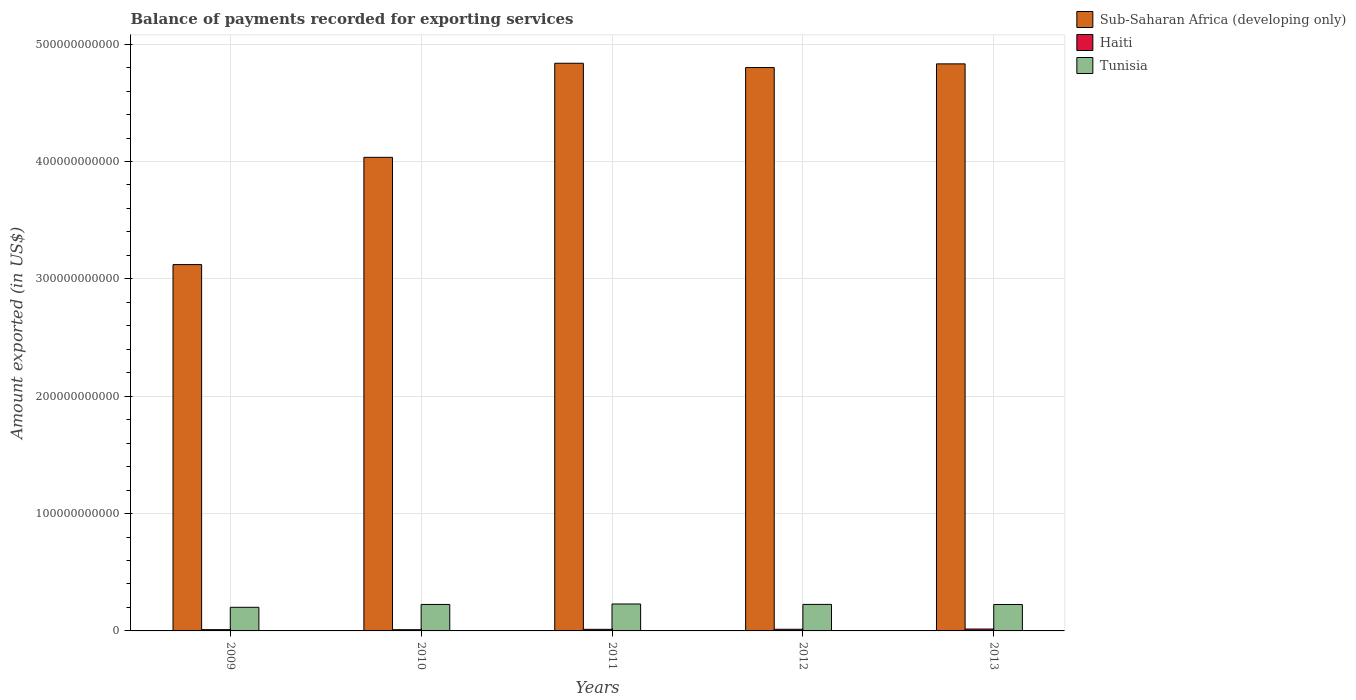How many groups of bars are there?
Offer a terse response. 5. How many bars are there on the 1st tick from the right?
Provide a short and direct response. 3. What is the amount exported in Haiti in 2010?
Keep it short and to the point. 1.05e+09. Across all years, what is the maximum amount exported in Sub-Saharan Africa (developing only)?
Ensure brevity in your answer.  4.84e+11. Across all years, what is the minimum amount exported in Sub-Saharan Africa (developing only)?
Make the answer very short. 3.12e+11. In which year was the amount exported in Haiti maximum?
Your answer should be very brief. 2013. What is the total amount exported in Sub-Saharan Africa (developing only) in the graph?
Make the answer very short. 2.16e+12. What is the difference between the amount exported in Sub-Saharan Africa (developing only) in 2011 and that in 2013?
Ensure brevity in your answer.  5.22e+08. What is the difference between the amount exported in Haiti in 2011 and the amount exported in Tunisia in 2009?
Your answer should be compact. -1.88e+1. What is the average amount exported in Tunisia per year?
Keep it short and to the point. 2.22e+1. In the year 2011, what is the difference between the amount exported in Sub-Saharan Africa (developing only) and amount exported in Haiti?
Your answer should be very brief. 4.82e+11. What is the ratio of the amount exported in Tunisia in 2009 to that in 2013?
Offer a terse response. 0.89. Is the amount exported in Sub-Saharan Africa (developing only) in 2009 less than that in 2012?
Your response must be concise. Yes. Is the difference between the amount exported in Sub-Saharan Africa (developing only) in 2010 and 2012 greater than the difference between the amount exported in Haiti in 2010 and 2012?
Offer a very short reply. No. What is the difference between the highest and the second highest amount exported in Tunisia?
Offer a very short reply. 3.50e+08. What is the difference between the highest and the lowest amount exported in Tunisia?
Keep it short and to the point. 2.82e+09. Is the sum of the amount exported in Haiti in 2011 and 2013 greater than the maximum amount exported in Tunisia across all years?
Your response must be concise. No. What does the 3rd bar from the left in 2010 represents?
Your response must be concise. Tunisia. What does the 1st bar from the right in 2011 represents?
Keep it short and to the point. Tunisia. How many bars are there?
Your answer should be very brief. 15. What is the difference between two consecutive major ticks on the Y-axis?
Your answer should be compact. 1.00e+11. Does the graph contain any zero values?
Keep it short and to the point. No. Where does the legend appear in the graph?
Offer a very short reply. Top right. How many legend labels are there?
Your answer should be very brief. 3. How are the legend labels stacked?
Make the answer very short. Vertical. What is the title of the graph?
Offer a very short reply. Balance of payments recorded for exporting services. Does "Haiti" appear as one of the legend labels in the graph?
Make the answer very short. Yes. What is the label or title of the Y-axis?
Provide a short and direct response. Amount exported (in US$). What is the Amount exported (in US$) of Sub-Saharan Africa (developing only) in 2009?
Your answer should be very brief. 3.12e+11. What is the Amount exported (in US$) of Haiti in 2009?
Ensure brevity in your answer.  1.07e+09. What is the Amount exported (in US$) in Tunisia in 2009?
Offer a very short reply. 2.01e+1. What is the Amount exported (in US$) of Sub-Saharan Africa (developing only) in 2010?
Your response must be concise. 4.04e+11. What is the Amount exported (in US$) in Haiti in 2010?
Offer a terse response. 1.05e+09. What is the Amount exported (in US$) of Tunisia in 2010?
Your response must be concise. 2.26e+1. What is the Amount exported (in US$) of Sub-Saharan Africa (developing only) in 2011?
Give a very brief answer. 4.84e+11. What is the Amount exported (in US$) of Haiti in 2011?
Offer a terse response. 1.36e+09. What is the Amount exported (in US$) in Tunisia in 2011?
Your response must be concise. 2.30e+1. What is the Amount exported (in US$) of Sub-Saharan Africa (developing only) in 2012?
Your answer should be compact. 4.80e+11. What is the Amount exported (in US$) of Haiti in 2012?
Your answer should be very brief. 1.40e+09. What is the Amount exported (in US$) in Tunisia in 2012?
Give a very brief answer. 2.26e+1. What is the Amount exported (in US$) in Sub-Saharan Africa (developing only) in 2013?
Provide a succinct answer. 4.83e+11. What is the Amount exported (in US$) of Haiti in 2013?
Your response must be concise. 1.61e+09. What is the Amount exported (in US$) in Tunisia in 2013?
Ensure brevity in your answer.  2.25e+1. Across all years, what is the maximum Amount exported (in US$) in Sub-Saharan Africa (developing only)?
Offer a terse response. 4.84e+11. Across all years, what is the maximum Amount exported (in US$) of Haiti?
Give a very brief answer. 1.61e+09. Across all years, what is the maximum Amount exported (in US$) of Tunisia?
Your response must be concise. 2.30e+1. Across all years, what is the minimum Amount exported (in US$) in Sub-Saharan Africa (developing only)?
Your answer should be compact. 3.12e+11. Across all years, what is the minimum Amount exported (in US$) of Haiti?
Provide a short and direct response. 1.05e+09. Across all years, what is the minimum Amount exported (in US$) of Tunisia?
Your answer should be compact. 2.01e+1. What is the total Amount exported (in US$) in Sub-Saharan Africa (developing only) in the graph?
Your answer should be very brief. 2.16e+12. What is the total Amount exported (in US$) of Haiti in the graph?
Make the answer very short. 6.48e+09. What is the total Amount exported (in US$) of Tunisia in the graph?
Your answer should be very brief. 1.11e+11. What is the difference between the Amount exported (in US$) of Sub-Saharan Africa (developing only) in 2009 and that in 2010?
Offer a very short reply. -9.14e+1. What is the difference between the Amount exported (in US$) of Haiti in 2009 and that in 2010?
Ensure brevity in your answer.  1.60e+07. What is the difference between the Amount exported (in US$) of Tunisia in 2009 and that in 2010?
Offer a terse response. -2.42e+09. What is the difference between the Amount exported (in US$) in Sub-Saharan Africa (developing only) in 2009 and that in 2011?
Keep it short and to the point. -1.72e+11. What is the difference between the Amount exported (in US$) in Haiti in 2009 and that in 2011?
Provide a succinct answer. -2.91e+08. What is the difference between the Amount exported (in US$) in Tunisia in 2009 and that in 2011?
Your answer should be compact. -2.82e+09. What is the difference between the Amount exported (in US$) in Sub-Saharan Africa (developing only) in 2009 and that in 2012?
Provide a succinct answer. -1.68e+11. What is the difference between the Amount exported (in US$) of Haiti in 2009 and that in 2012?
Your response must be concise. -3.35e+08. What is the difference between the Amount exported (in US$) of Tunisia in 2009 and that in 2012?
Keep it short and to the point. -2.47e+09. What is the difference between the Amount exported (in US$) in Sub-Saharan Africa (developing only) in 2009 and that in 2013?
Give a very brief answer. -1.71e+11. What is the difference between the Amount exported (in US$) in Haiti in 2009 and that in 2013?
Ensure brevity in your answer.  -5.43e+08. What is the difference between the Amount exported (in US$) of Tunisia in 2009 and that in 2013?
Provide a succinct answer. -2.38e+09. What is the difference between the Amount exported (in US$) of Sub-Saharan Africa (developing only) in 2010 and that in 2011?
Keep it short and to the point. -8.02e+1. What is the difference between the Amount exported (in US$) of Haiti in 2010 and that in 2011?
Your answer should be compact. -3.07e+08. What is the difference between the Amount exported (in US$) of Tunisia in 2010 and that in 2011?
Your answer should be very brief. -3.94e+08. What is the difference between the Amount exported (in US$) of Sub-Saharan Africa (developing only) in 2010 and that in 2012?
Your answer should be very brief. -7.65e+1. What is the difference between the Amount exported (in US$) of Haiti in 2010 and that in 2012?
Give a very brief answer. -3.51e+08. What is the difference between the Amount exported (in US$) in Tunisia in 2010 and that in 2012?
Your answer should be very brief. -4.48e+07. What is the difference between the Amount exported (in US$) of Sub-Saharan Africa (developing only) in 2010 and that in 2013?
Your answer should be very brief. -7.96e+1. What is the difference between the Amount exported (in US$) of Haiti in 2010 and that in 2013?
Make the answer very short. -5.59e+08. What is the difference between the Amount exported (in US$) in Tunisia in 2010 and that in 2013?
Provide a short and direct response. 4.27e+07. What is the difference between the Amount exported (in US$) of Sub-Saharan Africa (developing only) in 2011 and that in 2012?
Ensure brevity in your answer.  3.65e+09. What is the difference between the Amount exported (in US$) in Haiti in 2011 and that in 2012?
Provide a succinct answer. -4.43e+07. What is the difference between the Amount exported (in US$) in Tunisia in 2011 and that in 2012?
Your answer should be very brief. 3.50e+08. What is the difference between the Amount exported (in US$) of Sub-Saharan Africa (developing only) in 2011 and that in 2013?
Ensure brevity in your answer.  5.22e+08. What is the difference between the Amount exported (in US$) in Haiti in 2011 and that in 2013?
Make the answer very short. -2.52e+08. What is the difference between the Amount exported (in US$) in Tunisia in 2011 and that in 2013?
Ensure brevity in your answer.  4.37e+08. What is the difference between the Amount exported (in US$) in Sub-Saharan Africa (developing only) in 2012 and that in 2013?
Ensure brevity in your answer.  -3.13e+09. What is the difference between the Amount exported (in US$) in Haiti in 2012 and that in 2013?
Your answer should be very brief. -2.08e+08. What is the difference between the Amount exported (in US$) in Tunisia in 2012 and that in 2013?
Provide a short and direct response. 8.75e+07. What is the difference between the Amount exported (in US$) of Sub-Saharan Africa (developing only) in 2009 and the Amount exported (in US$) of Haiti in 2010?
Your answer should be compact. 3.11e+11. What is the difference between the Amount exported (in US$) of Sub-Saharan Africa (developing only) in 2009 and the Amount exported (in US$) of Tunisia in 2010?
Ensure brevity in your answer.  2.90e+11. What is the difference between the Amount exported (in US$) of Haiti in 2009 and the Amount exported (in US$) of Tunisia in 2010?
Offer a terse response. -2.15e+1. What is the difference between the Amount exported (in US$) of Sub-Saharan Africa (developing only) in 2009 and the Amount exported (in US$) of Haiti in 2011?
Offer a terse response. 3.11e+11. What is the difference between the Amount exported (in US$) in Sub-Saharan Africa (developing only) in 2009 and the Amount exported (in US$) in Tunisia in 2011?
Your answer should be compact. 2.89e+11. What is the difference between the Amount exported (in US$) of Haiti in 2009 and the Amount exported (in US$) of Tunisia in 2011?
Your answer should be very brief. -2.19e+1. What is the difference between the Amount exported (in US$) of Sub-Saharan Africa (developing only) in 2009 and the Amount exported (in US$) of Haiti in 2012?
Offer a terse response. 3.11e+11. What is the difference between the Amount exported (in US$) of Sub-Saharan Africa (developing only) in 2009 and the Amount exported (in US$) of Tunisia in 2012?
Offer a terse response. 2.90e+11. What is the difference between the Amount exported (in US$) in Haiti in 2009 and the Amount exported (in US$) in Tunisia in 2012?
Offer a very short reply. -2.15e+1. What is the difference between the Amount exported (in US$) in Sub-Saharan Africa (developing only) in 2009 and the Amount exported (in US$) in Haiti in 2013?
Give a very brief answer. 3.11e+11. What is the difference between the Amount exported (in US$) of Sub-Saharan Africa (developing only) in 2009 and the Amount exported (in US$) of Tunisia in 2013?
Give a very brief answer. 2.90e+11. What is the difference between the Amount exported (in US$) of Haiti in 2009 and the Amount exported (in US$) of Tunisia in 2013?
Offer a terse response. -2.14e+1. What is the difference between the Amount exported (in US$) in Sub-Saharan Africa (developing only) in 2010 and the Amount exported (in US$) in Haiti in 2011?
Ensure brevity in your answer.  4.02e+11. What is the difference between the Amount exported (in US$) of Sub-Saharan Africa (developing only) in 2010 and the Amount exported (in US$) of Tunisia in 2011?
Your response must be concise. 3.81e+11. What is the difference between the Amount exported (in US$) in Haiti in 2010 and the Amount exported (in US$) in Tunisia in 2011?
Provide a succinct answer. -2.19e+1. What is the difference between the Amount exported (in US$) of Sub-Saharan Africa (developing only) in 2010 and the Amount exported (in US$) of Haiti in 2012?
Offer a very short reply. 4.02e+11. What is the difference between the Amount exported (in US$) in Sub-Saharan Africa (developing only) in 2010 and the Amount exported (in US$) in Tunisia in 2012?
Provide a short and direct response. 3.81e+11. What is the difference between the Amount exported (in US$) of Haiti in 2010 and the Amount exported (in US$) of Tunisia in 2012?
Offer a very short reply. -2.16e+1. What is the difference between the Amount exported (in US$) in Sub-Saharan Africa (developing only) in 2010 and the Amount exported (in US$) in Haiti in 2013?
Make the answer very short. 4.02e+11. What is the difference between the Amount exported (in US$) in Sub-Saharan Africa (developing only) in 2010 and the Amount exported (in US$) in Tunisia in 2013?
Offer a terse response. 3.81e+11. What is the difference between the Amount exported (in US$) in Haiti in 2010 and the Amount exported (in US$) in Tunisia in 2013?
Provide a short and direct response. -2.15e+1. What is the difference between the Amount exported (in US$) in Sub-Saharan Africa (developing only) in 2011 and the Amount exported (in US$) in Haiti in 2012?
Your response must be concise. 4.82e+11. What is the difference between the Amount exported (in US$) in Sub-Saharan Africa (developing only) in 2011 and the Amount exported (in US$) in Tunisia in 2012?
Keep it short and to the point. 4.61e+11. What is the difference between the Amount exported (in US$) in Haiti in 2011 and the Amount exported (in US$) in Tunisia in 2012?
Your response must be concise. -2.12e+1. What is the difference between the Amount exported (in US$) in Sub-Saharan Africa (developing only) in 2011 and the Amount exported (in US$) in Haiti in 2013?
Ensure brevity in your answer.  4.82e+11. What is the difference between the Amount exported (in US$) in Sub-Saharan Africa (developing only) in 2011 and the Amount exported (in US$) in Tunisia in 2013?
Your answer should be very brief. 4.61e+11. What is the difference between the Amount exported (in US$) of Haiti in 2011 and the Amount exported (in US$) of Tunisia in 2013?
Give a very brief answer. -2.12e+1. What is the difference between the Amount exported (in US$) in Sub-Saharan Africa (developing only) in 2012 and the Amount exported (in US$) in Haiti in 2013?
Your answer should be very brief. 4.78e+11. What is the difference between the Amount exported (in US$) of Sub-Saharan Africa (developing only) in 2012 and the Amount exported (in US$) of Tunisia in 2013?
Your answer should be very brief. 4.58e+11. What is the difference between the Amount exported (in US$) in Haiti in 2012 and the Amount exported (in US$) in Tunisia in 2013?
Provide a succinct answer. -2.11e+1. What is the average Amount exported (in US$) in Sub-Saharan Africa (developing only) per year?
Provide a short and direct response. 4.33e+11. What is the average Amount exported (in US$) in Haiti per year?
Your answer should be compact. 1.30e+09. What is the average Amount exported (in US$) in Tunisia per year?
Your answer should be compact. 2.22e+1. In the year 2009, what is the difference between the Amount exported (in US$) of Sub-Saharan Africa (developing only) and Amount exported (in US$) of Haiti?
Your response must be concise. 3.11e+11. In the year 2009, what is the difference between the Amount exported (in US$) of Sub-Saharan Africa (developing only) and Amount exported (in US$) of Tunisia?
Offer a terse response. 2.92e+11. In the year 2009, what is the difference between the Amount exported (in US$) in Haiti and Amount exported (in US$) in Tunisia?
Provide a short and direct response. -1.91e+1. In the year 2010, what is the difference between the Amount exported (in US$) in Sub-Saharan Africa (developing only) and Amount exported (in US$) in Haiti?
Your answer should be very brief. 4.02e+11. In the year 2010, what is the difference between the Amount exported (in US$) of Sub-Saharan Africa (developing only) and Amount exported (in US$) of Tunisia?
Your answer should be very brief. 3.81e+11. In the year 2010, what is the difference between the Amount exported (in US$) in Haiti and Amount exported (in US$) in Tunisia?
Keep it short and to the point. -2.15e+1. In the year 2011, what is the difference between the Amount exported (in US$) in Sub-Saharan Africa (developing only) and Amount exported (in US$) in Haiti?
Provide a short and direct response. 4.82e+11. In the year 2011, what is the difference between the Amount exported (in US$) of Sub-Saharan Africa (developing only) and Amount exported (in US$) of Tunisia?
Keep it short and to the point. 4.61e+11. In the year 2011, what is the difference between the Amount exported (in US$) in Haiti and Amount exported (in US$) in Tunisia?
Your answer should be compact. -2.16e+1. In the year 2012, what is the difference between the Amount exported (in US$) of Sub-Saharan Africa (developing only) and Amount exported (in US$) of Haiti?
Ensure brevity in your answer.  4.79e+11. In the year 2012, what is the difference between the Amount exported (in US$) in Sub-Saharan Africa (developing only) and Amount exported (in US$) in Tunisia?
Give a very brief answer. 4.57e+11. In the year 2012, what is the difference between the Amount exported (in US$) in Haiti and Amount exported (in US$) in Tunisia?
Your response must be concise. -2.12e+1. In the year 2013, what is the difference between the Amount exported (in US$) of Sub-Saharan Africa (developing only) and Amount exported (in US$) of Haiti?
Your answer should be very brief. 4.82e+11. In the year 2013, what is the difference between the Amount exported (in US$) in Sub-Saharan Africa (developing only) and Amount exported (in US$) in Tunisia?
Your answer should be compact. 4.61e+11. In the year 2013, what is the difference between the Amount exported (in US$) of Haiti and Amount exported (in US$) of Tunisia?
Keep it short and to the point. -2.09e+1. What is the ratio of the Amount exported (in US$) in Sub-Saharan Africa (developing only) in 2009 to that in 2010?
Keep it short and to the point. 0.77. What is the ratio of the Amount exported (in US$) in Haiti in 2009 to that in 2010?
Your response must be concise. 1.02. What is the ratio of the Amount exported (in US$) in Tunisia in 2009 to that in 2010?
Offer a terse response. 0.89. What is the ratio of the Amount exported (in US$) in Sub-Saharan Africa (developing only) in 2009 to that in 2011?
Keep it short and to the point. 0.65. What is the ratio of the Amount exported (in US$) of Haiti in 2009 to that in 2011?
Your response must be concise. 0.79. What is the ratio of the Amount exported (in US$) in Tunisia in 2009 to that in 2011?
Your answer should be very brief. 0.88. What is the ratio of the Amount exported (in US$) in Sub-Saharan Africa (developing only) in 2009 to that in 2012?
Provide a succinct answer. 0.65. What is the ratio of the Amount exported (in US$) in Haiti in 2009 to that in 2012?
Offer a very short reply. 0.76. What is the ratio of the Amount exported (in US$) of Tunisia in 2009 to that in 2012?
Provide a short and direct response. 0.89. What is the ratio of the Amount exported (in US$) in Sub-Saharan Africa (developing only) in 2009 to that in 2013?
Provide a short and direct response. 0.65. What is the ratio of the Amount exported (in US$) in Haiti in 2009 to that in 2013?
Make the answer very short. 0.66. What is the ratio of the Amount exported (in US$) in Tunisia in 2009 to that in 2013?
Make the answer very short. 0.89. What is the ratio of the Amount exported (in US$) of Sub-Saharan Africa (developing only) in 2010 to that in 2011?
Give a very brief answer. 0.83. What is the ratio of the Amount exported (in US$) of Haiti in 2010 to that in 2011?
Offer a terse response. 0.77. What is the ratio of the Amount exported (in US$) in Tunisia in 2010 to that in 2011?
Your answer should be compact. 0.98. What is the ratio of the Amount exported (in US$) of Sub-Saharan Africa (developing only) in 2010 to that in 2012?
Provide a succinct answer. 0.84. What is the ratio of the Amount exported (in US$) of Haiti in 2010 to that in 2012?
Offer a very short reply. 0.75. What is the ratio of the Amount exported (in US$) of Tunisia in 2010 to that in 2012?
Provide a short and direct response. 1. What is the ratio of the Amount exported (in US$) in Sub-Saharan Africa (developing only) in 2010 to that in 2013?
Keep it short and to the point. 0.84. What is the ratio of the Amount exported (in US$) of Haiti in 2010 to that in 2013?
Make the answer very short. 0.65. What is the ratio of the Amount exported (in US$) of Tunisia in 2010 to that in 2013?
Provide a succinct answer. 1. What is the ratio of the Amount exported (in US$) in Sub-Saharan Africa (developing only) in 2011 to that in 2012?
Your answer should be compact. 1.01. What is the ratio of the Amount exported (in US$) of Haiti in 2011 to that in 2012?
Offer a terse response. 0.97. What is the ratio of the Amount exported (in US$) of Tunisia in 2011 to that in 2012?
Make the answer very short. 1.02. What is the ratio of the Amount exported (in US$) in Haiti in 2011 to that in 2013?
Provide a succinct answer. 0.84. What is the ratio of the Amount exported (in US$) of Tunisia in 2011 to that in 2013?
Provide a succinct answer. 1.02. What is the ratio of the Amount exported (in US$) of Haiti in 2012 to that in 2013?
Your response must be concise. 0.87. What is the ratio of the Amount exported (in US$) in Tunisia in 2012 to that in 2013?
Keep it short and to the point. 1. What is the difference between the highest and the second highest Amount exported (in US$) of Sub-Saharan Africa (developing only)?
Provide a succinct answer. 5.22e+08. What is the difference between the highest and the second highest Amount exported (in US$) of Haiti?
Your answer should be compact. 2.08e+08. What is the difference between the highest and the second highest Amount exported (in US$) in Tunisia?
Provide a short and direct response. 3.50e+08. What is the difference between the highest and the lowest Amount exported (in US$) of Sub-Saharan Africa (developing only)?
Keep it short and to the point. 1.72e+11. What is the difference between the highest and the lowest Amount exported (in US$) in Haiti?
Give a very brief answer. 5.59e+08. What is the difference between the highest and the lowest Amount exported (in US$) of Tunisia?
Ensure brevity in your answer.  2.82e+09. 